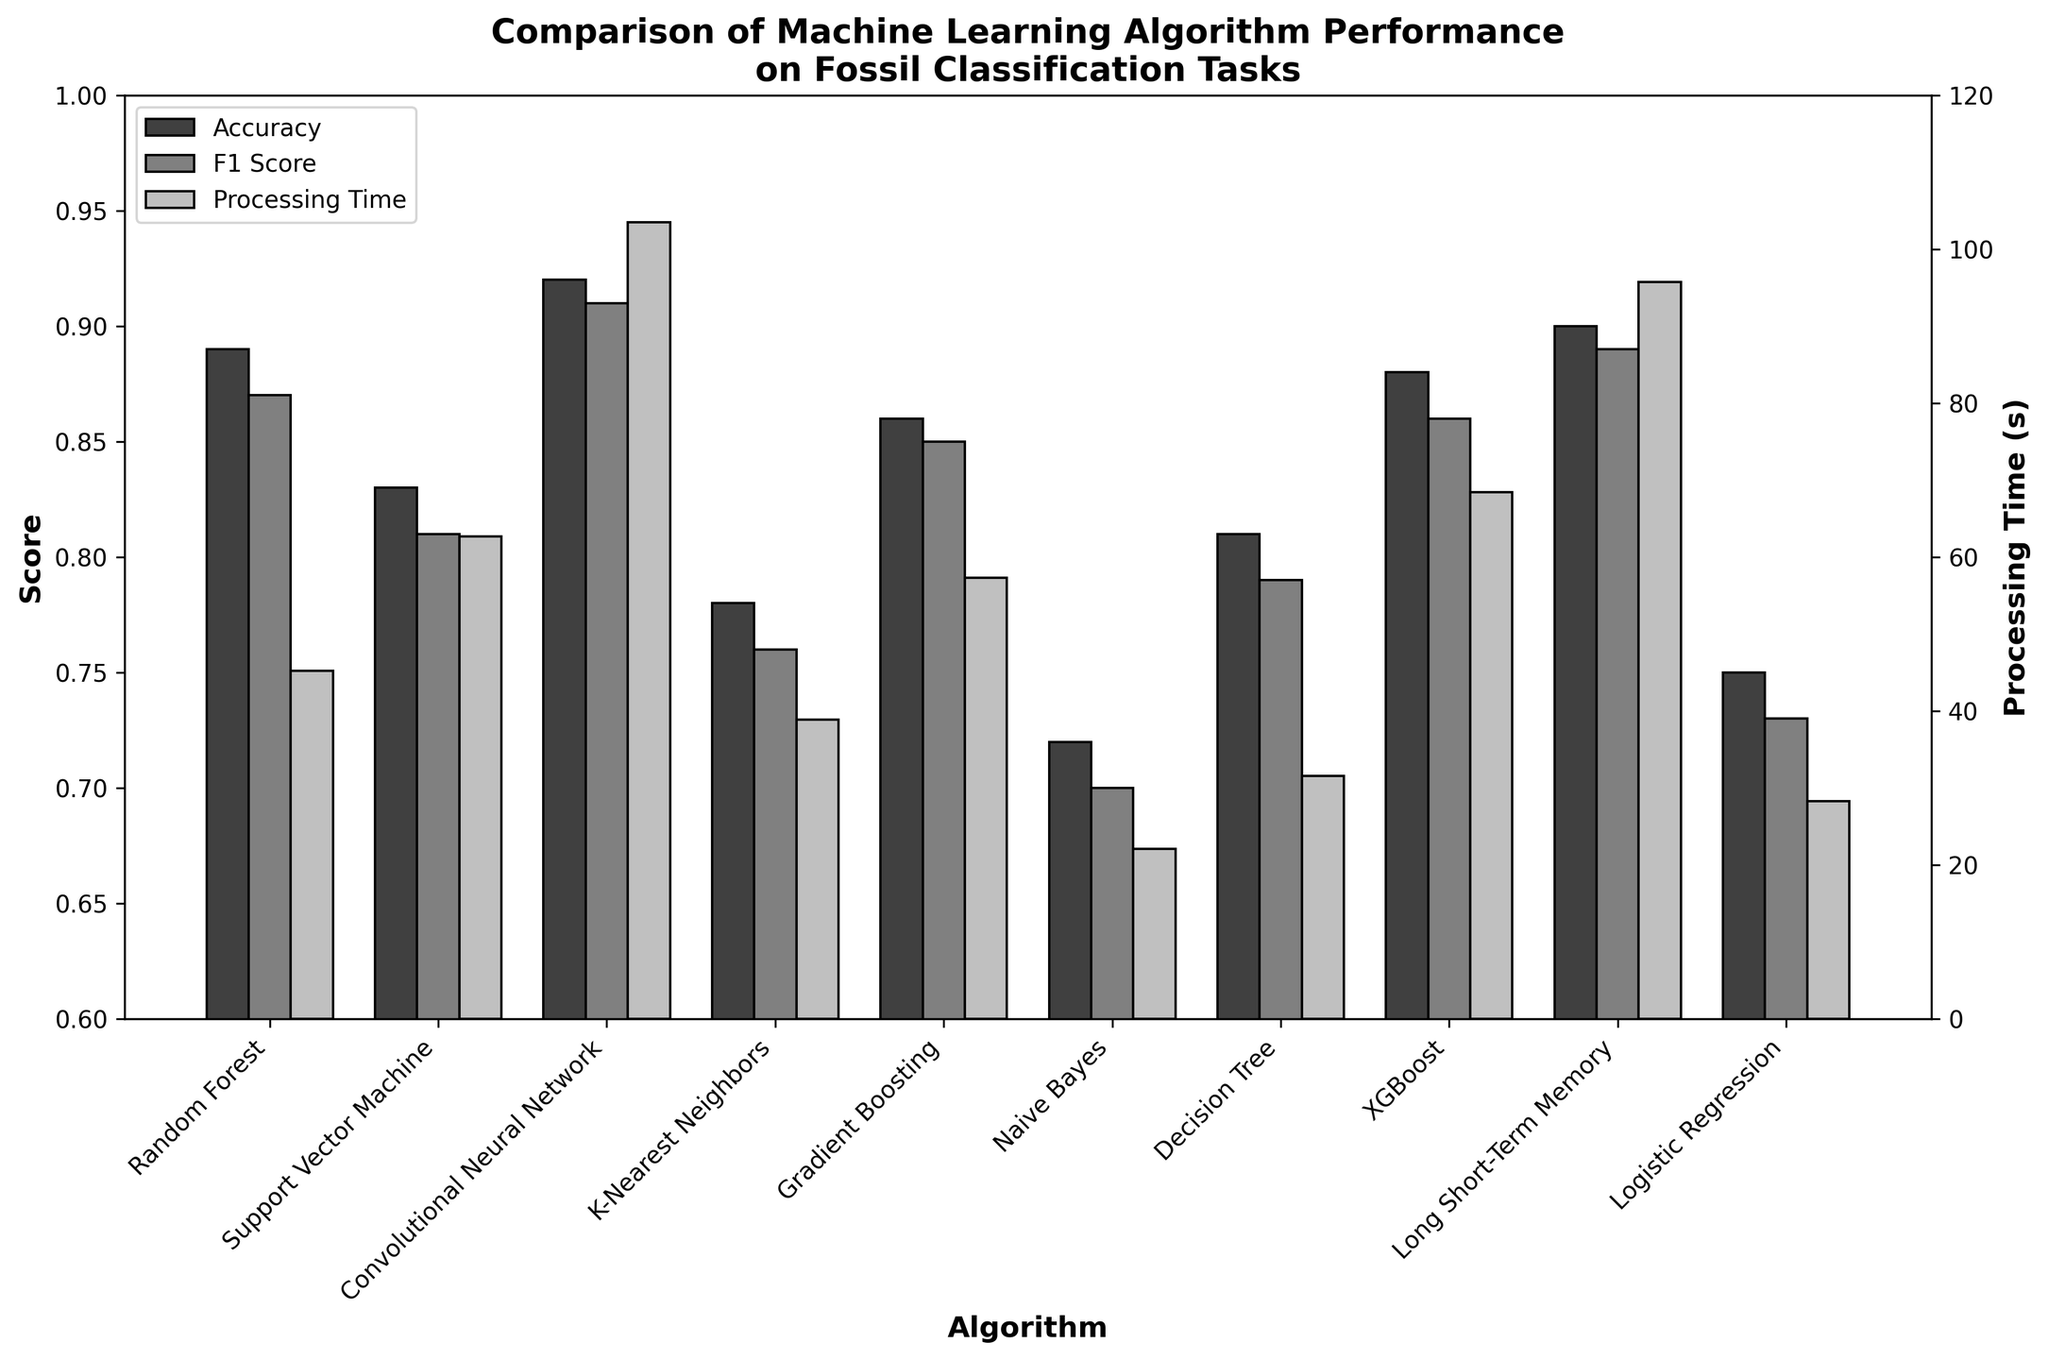What algorithm has the highest accuracy? The Convolutional Neural Network (CNN) bar is the highest in the accuracy group.
Answer: Convolutional Neural Network Which algorithm has the lowest F1 score? The Naive Bayes bar is the shortest in the F1 score group.
Answer: Naive Bayes What is the processing time difference between the Convolutional Neural Network and K-Nearest Neighbors? Look at the Convolutional Neural Network bar for processing time (103.5s) and the K-Nearest Neighbors (38.9s), then subtract the latter from the former.
Answer: 64.6s Which algorithm has a higher processing time: Gradient Boosting or Logistic Regression? The Gradient Boosting bar is taller compared to the Logistic Regression bar in the processing time group.
Answer: Gradient Boosting What is the average F1 score of the algorithms? Sum the F1 scores of all algorithms (0.87 + 0.81 + 0.91 + 0.76 + 0.85 + 0.70 + 0.79 + 0.86 + 0.89 + 0.73) = 7.17; then divide by the number of algorithms (10).
Answer: 0.717 Which algorithms have a processing time of less than 40 seconds? Identify the algorithms where the processing time bars are shorter than the 40-second mark: K-Nearest Neighbors (38.9s), Naive Bayes (22.1s), and Decision Tree (31.6s).
Answer: K-Nearest Neighbors, Naive Bayes, Decision Tree What is the difference in accuracy between the algorithm with the highest accuracy and the algorithm with the lowest accuracy? The highest accuracy is for Convolutional Neural Network (0.92) and the lowest is for Naive Bayes (0.72). Subtract the latter from the former.
Answer: 0.20 Which algorithm has similar scores for accuracy and F1 score? Compare the heights of the bars for accuracy and F1 score. Random Forest (0.89 vs 0.87), Gradient Boosting (0.86 vs 0.85), Convolutional Neural Network (0.92 vs 0.91), Long Short-Term Memory (0.90 vs 0.89), and XGBoost (0.88 vs 0.86) have close values.
Answer: Random Forest, Gradient Boosting, Convolutional Neural Network, Long Short-Term Memory, XGBoost Which algorithm performs better in terms of accuracy, Random Forest or Support Vector Machine? The accuracy bar for Random Forest is taller (0.89) compared to Support Vector Machine (0.83).
Answer: Random Forest What is the combined processing time for Logistic Regression and Naive Bayes? Add the processing times of Logistic Regression (28.3s) and Naive Bayes (22.1s).
Answer: 50.4s 